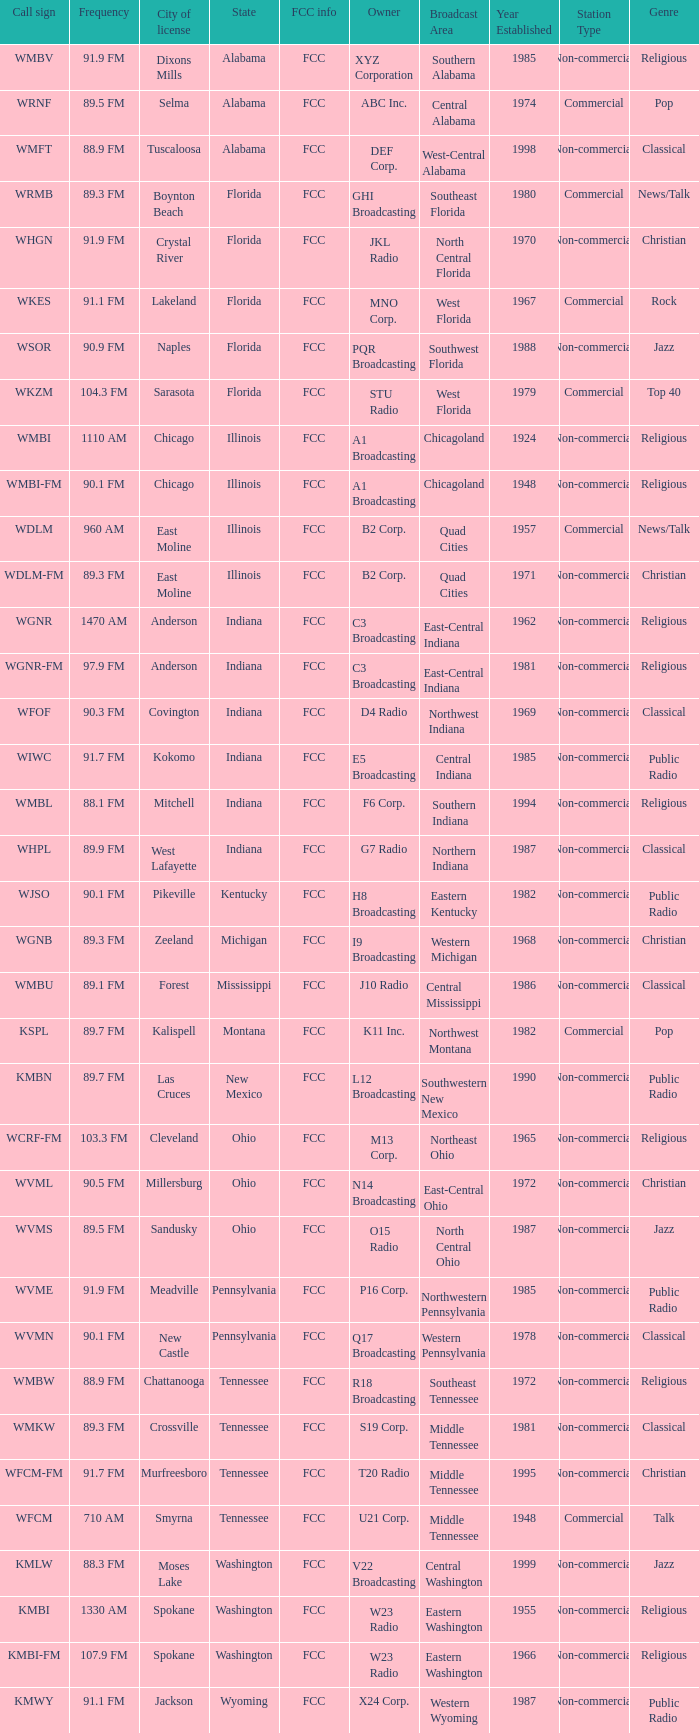What state is the radio station in that has a frequency of 90.1 FM and a city license in New Castle? Pennsylvania. Would you mind parsing the complete table? {'header': ['Call sign', 'Frequency', 'City of license', 'State', 'FCC info', 'Owner', 'Broadcast Area', 'Year Established', 'Station Type', 'Genre'], 'rows': [['WMBV', '91.9 FM', 'Dixons Mills', 'Alabama', 'FCC', 'XYZ Corporation', 'Southern Alabama', '1985', 'Non-commercial', 'Religious'], ['WRNF', '89.5 FM', 'Selma', 'Alabama', 'FCC', 'ABC Inc.', 'Central Alabama', '1974', 'Commercial', 'Pop'], ['WMFT', '88.9 FM', 'Tuscaloosa', 'Alabama', 'FCC', 'DEF Corp.', 'West-Central Alabama', '1998', 'Non-commercial', 'Classical'], ['WRMB', '89.3 FM', 'Boynton Beach', 'Florida', 'FCC', 'GHI Broadcasting', 'Southeast Florida', '1980', 'Commercial', 'News/Talk'], ['WHGN', '91.9 FM', 'Crystal River', 'Florida', 'FCC', 'JKL Radio', 'North Central Florida', '1970', 'Non-commercial', 'Christian'], ['WKES', '91.1 FM', 'Lakeland', 'Florida', 'FCC', 'MNO Corp.', 'West Florida', '1967', 'Commercial', 'Rock'], ['WSOR', '90.9 FM', 'Naples', 'Florida', 'FCC', 'PQR Broadcasting', 'Southwest Florida', '1988', 'Non-commercial', 'Jazz'], ['WKZM', '104.3 FM', 'Sarasota', 'Florida', 'FCC', 'STU Radio', 'West Florida', '1979', 'Commercial', 'Top 40'], ['WMBI', '1110 AM', 'Chicago', 'Illinois', 'FCC', 'A1 Broadcasting', 'Chicagoland', '1924', 'Non-commercial', 'Religious'], ['WMBI-FM', '90.1 FM', 'Chicago', 'Illinois', 'FCC', 'A1 Broadcasting', 'Chicagoland', '1948', 'Non-commercial', 'Religious'], ['WDLM', '960 AM', 'East Moline', 'Illinois', 'FCC', 'B2 Corp.', 'Quad Cities', '1957', 'Commercial', 'News/Talk'], ['WDLM-FM', '89.3 FM', 'East Moline', 'Illinois', 'FCC', 'B2 Corp.', 'Quad Cities', '1971', 'Non-commercial', 'Christian'], ['WGNR', '1470 AM', 'Anderson', 'Indiana', 'FCC', 'C3 Broadcasting', 'East-Central Indiana', '1962', 'Non-commercial', 'Religious'], ['WGNR-FM', '97.9 FM', 'Anderson', 'Indiana', 'FCC', 'C3 Broadcasting', 'East-Central Indiana', '1981', 'Non-commercial', 'Religious'], ['WFOF', '90.3 FM', 'Covington', 'Indiana', 'FCC', 'D4 Radio', 'Northwest Indiana', '1969', 'Non-commercial', 'Classical'], ['WIWC', '91.7 FM', 'Kokomo', 'Indiana', 'FCC', 'E5 Broadcasting', 'Central Indiana', '1985', 'Non-commercial', 'Public Radio'], ['WMBL', '88.1 FM', 'Mitchell', 'Indiana', 'FCC', 'F6 Corp.', 'Southern Indiana', '1994', 'Non-commercial', 'Religious'], ['WHPL', '89.9 FM', 'West Lafayette', 'Indiana', 'FCC', 'G7 Radio', 'Northern Indiana', '1987', 'Non-commercial', 'Classical'], ['WJSO', '90.1 FM', 'Pikeville', 'Kentucky', 'FCC', 'H8 Broadcasting', 'Eastern Kentucky', '1982', 'Non-commercial', 'Public Radio'], ['WGNB', '89.3 FM', 'Zeeland', 'Michigan', 'FCC', 'I9 Broadcasting', 'Western Michigan', '1968', 'Non-commercial', 'Christian'], ['WMBU', '89.1 FM', 'Forest', 'Mississippi', 'FCC', 'J10 Radio', 'Central Mississippi', '1986', 'Non-commercial', 'Classical'], ['KSPL', '89.7 FM', 'Kalispell', 'Montana', 'FCC', 'K11 Inc.', 'Northwest Montana', '1982', 'Commercial', 'Pop'], ['KMBN', '89.7 FM', 'Las Cruces', 'New Mexico', 'FCC', 'L12 Broadcasting', 'Southwestern New Mexico', '1990', 'Non-commercial', 'Public Radio'], ['WCRF-FM', '103.3 FM', 'Cleveland', 'Ohio', 'FCC', 'M13 Corp.', 'Northeast Ohio', '1965', 'Non-commercial', 'Religious'], ['WVML', '90.5 FM', 'Millersburg', 'Ohio', 'FCC', 'N14 Broadcasting', 'East-Central Ohio', '1972', 'Non-commercial', 'Christian'], ['WVMS', '89.5 FM', 'Sandusky', 'Ohio', 'FCC', 'O15 Radio', 'North Central Ohio', '1987', 'Non-commercial', 'Jazz'], ['WVME', '91.9 FM', 'Meadville', 'Pennsylvania', 'FCC', 'P16 Corp.', 'Northwestern Pennsylvania', '1985', 'Non-commercial', 'Public Radio'], ['WVMN', '90.1 FM', 'New Castle', 'Pennsylvania', 'FCC', 'Q17 Broadcasting', 'Western Pennsylvania', '1978', 'Non-commercial', 'Classical'], ['WMBW', '88.9 FM', 'Chattanooga', 'Tennessee', 'FCC', 'R18 Broadcasting', 'Southeast Tennessee', '1972', 'Non-commercial', 'Religious'], ['WMKW', '89.3 FM', 'Crossville', 'Tennessee', 'FCC', 'S19 Corp.', 'Middle Tennessee', '1981', 'Non-commercial', 'Classical'], ['WFCM-FM', '91.7 FM', 'Murfreesboro', 'Tennessee', 'FCC', 'T20 Radio', 'Middle Tennessee', '1995', 'Non-commercial', 'Christian'], ['WFCM', '710 AM', 'Smyrna', 'Tennessee', 'FCC', 'U21 Corp.', 'Middle Tennessee', '1948', 'Commercial', 'Talk'], ['KMLW', '88.3 FM', 'Moses Lake', 'Washington', 'FCC', 'V22 Broadcasting', 'Central Washington', '1999', 'Non-commercial', 'Jazz'], ['KMBI', '1330 AM', 'Spokane', 'Washington', 'FCC', 'W23 Radio', 'Eastern Washington', '1955', 'Non-commercial', 'Religious'], ['KMBI-FM', '107.9 FM', 'Spokane', 'Washington', 'FCC', 'W23 Radio', 'Eastern Washington', '1966', 'Non-commercial', 'Religious'], ['KMWY', '91.1 FM', 'Jackson', 'Wyoming', 'FCC', 'X24 Corp.', 'Western Wyoming', '1987', 'Non-commercial', 'Public Radio']]} 